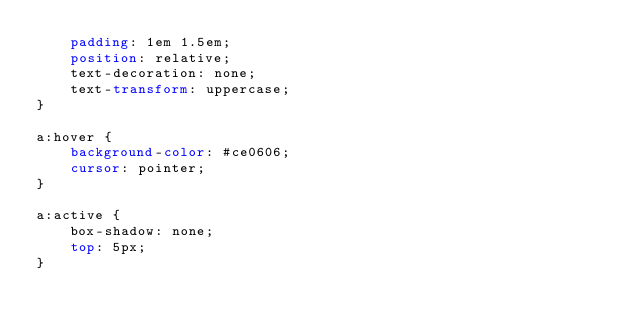<code> <loc_0><loc_0><loc_500><loc_500><_CSS_>    padding: 1em 1.5em;
    position: relative;
    text-decoration: none;
    text-transform: uppercase;
}
  
a:hover {
    background-color: #ce0606;
    cursor: pointer;
}
  
a:active {
    box-shadow: none;
    top: 5px;
}
</code> 